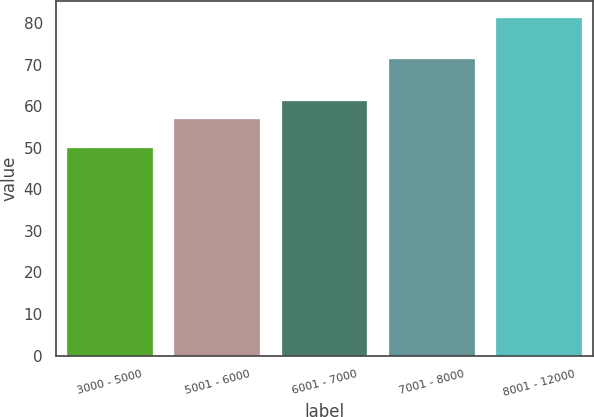Convert chart to OTSL. <chart><loc_0><loc_0><loc_500><loc_500><bar_chart><fcel>3000 - 5000<fcel>5001 - 6000<fcel>6001 - 7000<fcel>7001 - 8000<fcel>8001 - 12000<nl><fcel>49.95<fcel>56.97<fcel>61.17<fcel>71.22<fcel>81.11<nl></chart> 